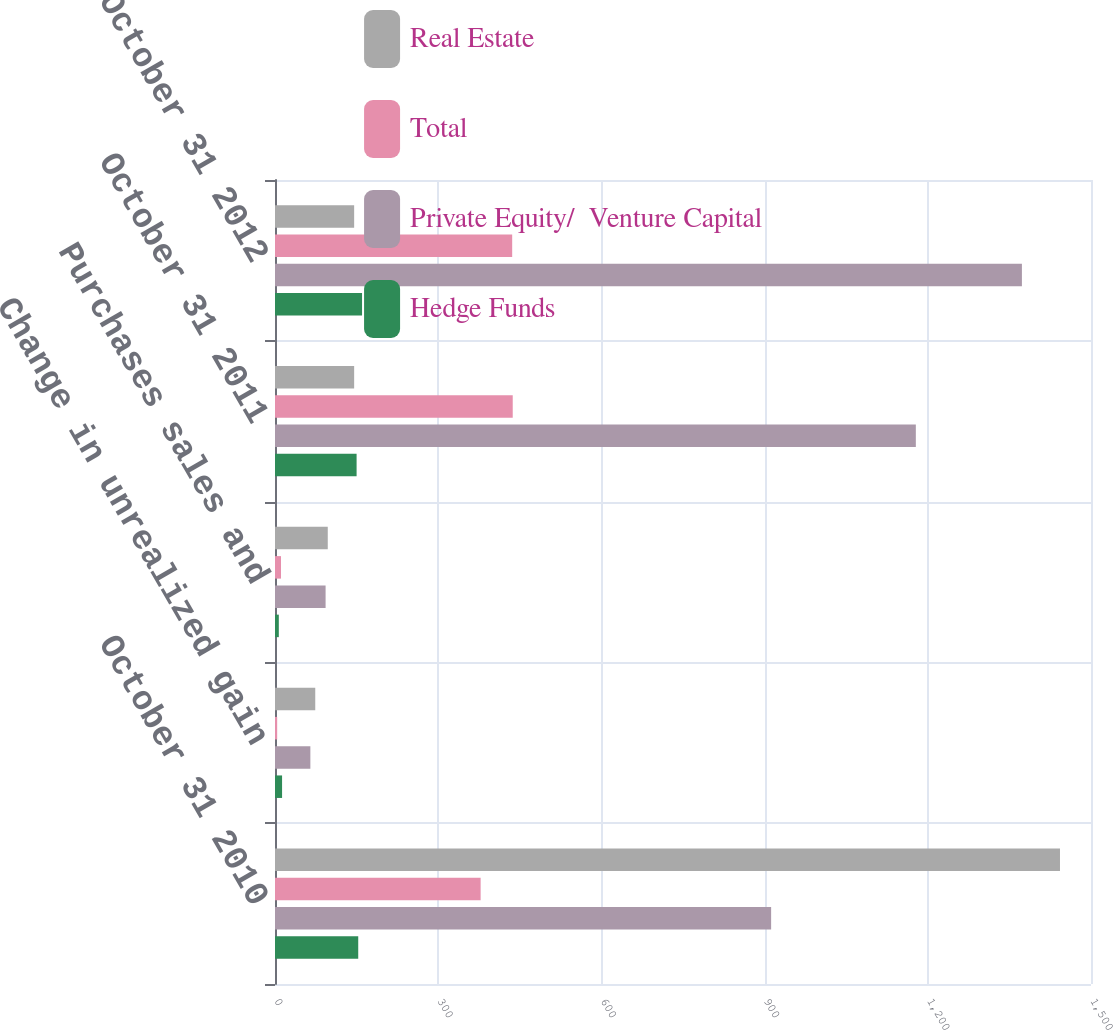Convert chart. <chart><loc_0><loc_0><loc_500><loc_500><stacked_bar_chart><ecel><fcel>October 31 2010<fcel>Change in unrealized gain<fcel>Purchases sales and<fcel>October 31 2011<fcel>October 31 2012<nl><fcel>Real Estate<fcel>1443<fcel>74<fcel>97<fcel>145.5<fcel>145.5<nl><fcel>Total<fcel>378<fcel>4<fcel>11<fcel>437<fcel>436<nl><fcel>Private Equity/  Venture Capital<fcel>912<fcel>65<fcel>93<fcel>1178<fcel>1373<nl><fcel>Hedge Funds<fcel>153<fcel>13<fcel>7<fcel>150<fcel>160<nl></chart> 